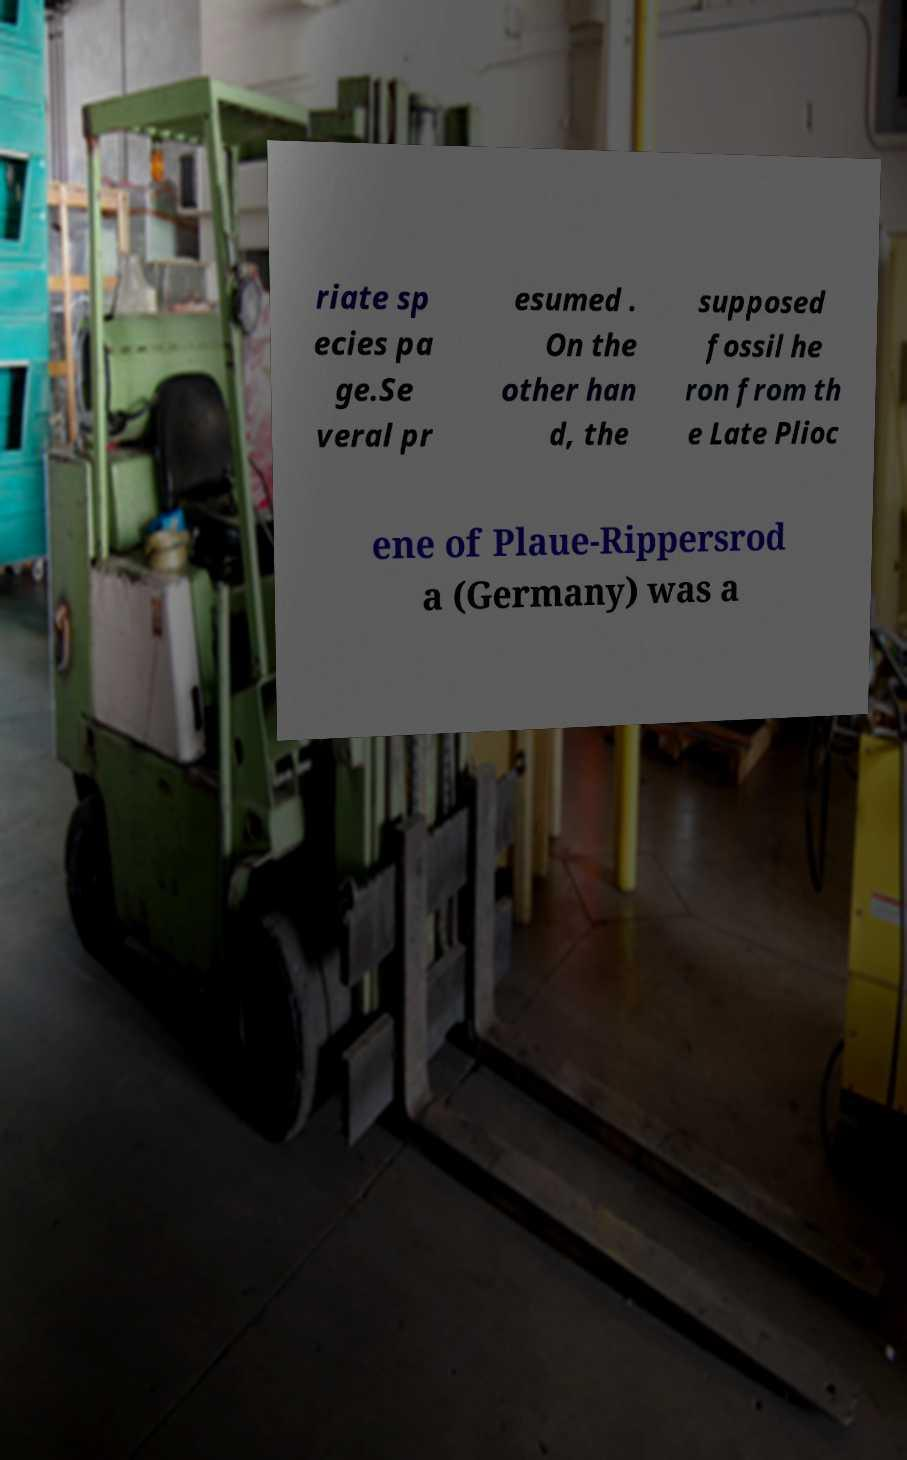Please read and relay the text visible in this image. What does it say? riate sp ecies pa ge.Se veral pr esumed . On the other han d, the supposed fossil he ron from th e Late Plioc ene of Plaue-Rippersrod a (Germany) was a 